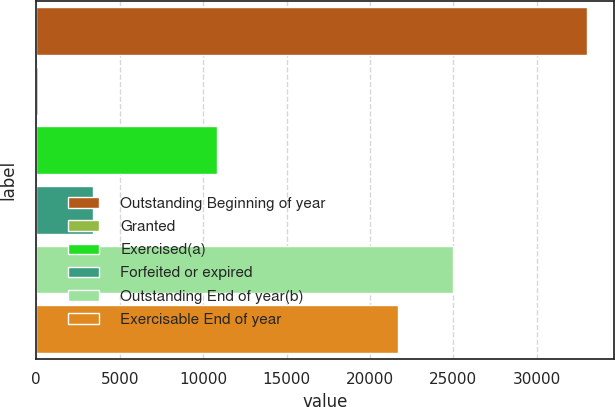Convert chart to OTSL. <chart><loc_0><loc_0><loc_500><loc_500><bar_chart><fcel>Outstanding Beginning of year<fcel>Granted<fcel>Exercised(a)<fcel>Forfeited or expired<fcel>Outstanding End of year(b)<fcel>Exercisable End of year<nl><fcel>33004<fcel>88<fcel>10820<fcel>3379.6<fcel>24985.6<fcel>21694<nl></chart> 